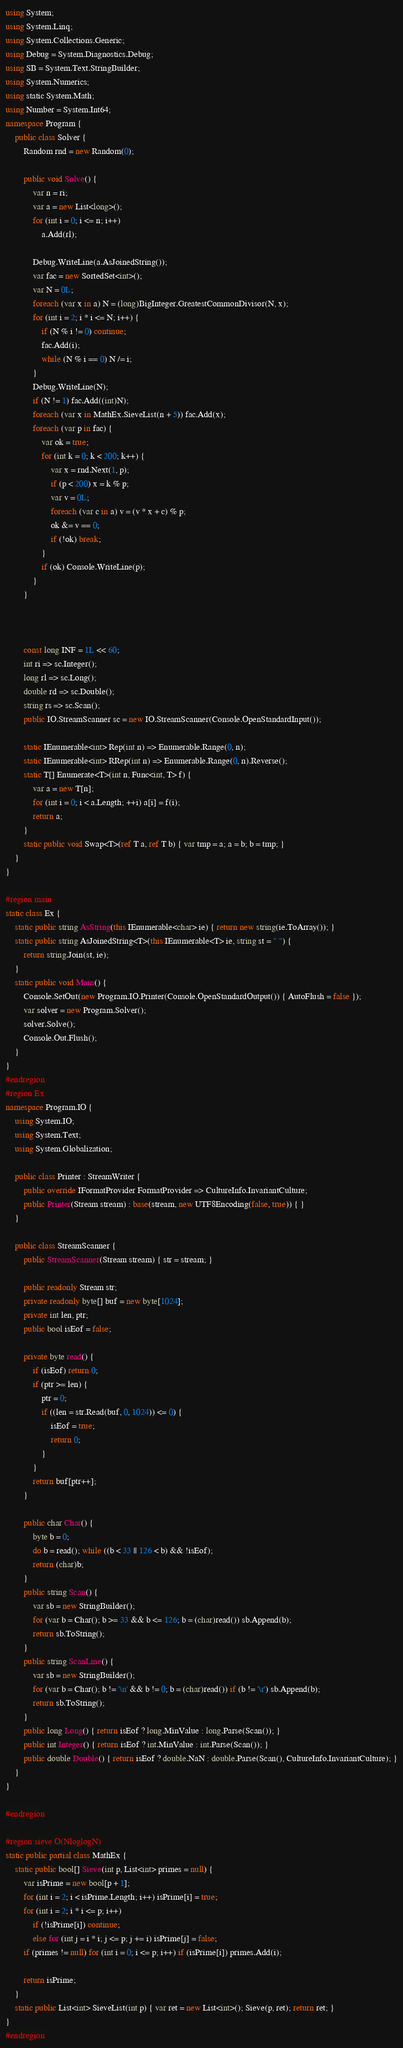Convert code to text. <code><loc_0><loc_0><loc_500><loc_500><_C#_>using System;
using System.Linq;
using System.Collections.Generic;
using Debug = System.Diagnostics.Debug;
using SB = System.Text.StringBuilder;
using System.Numerics;
using static System.Math;
using Number = System.Int64;
namespace Program {
    public class Solver {
        Random rnd = new Random(0);

        public void Solve() {
            var n = ri;
            var a = new List<long>();
            for (int i = 0; i <= n; i++)
                a.Add(rl);

            Debug.WriteLine(a.AsJoinedString());
            var fac = new SortedSet<int>();
            var N = 0L;
            foreach (var x in a) N = (long)BigInteger.GreatestCommonDivisor(N, x);
            for (int i = 2; i * i <= N; i++) {
                if (N % i != 0) continue;
                fac.Add(i);
                while (N % i == 0) N /= i;
            }
            Debug.WriteLine(N);
            if (N != 1) fac.Add((int)N);
            foreach (var x in MathEx.SieveList(n + 5)) fac.Add(x);
            foreach (var p in fac) {
                var ok = true;
                for (int k = 0; k < 200; k++) {
                    var x = rnd.Next(1, p);
                    if (p < 200) x = k % p;
                    var v = 0L;
                    foreach (var c in a) v = (v * x + c) % p;
                    ok &= v == 0;
                    if (!ok) break;
                }
                if (ok) Console.WriteLine(p);
            }
        }



        const long INF = 1L << 60;
        int ri => sc.Integer();
        long rl => sc.Long();
        double rd => sc.Double();
        string rs => sc.Scan();
        public IO.StreamScanner sc = new IO.StreamScanner(Console.OpenStandardInput());

        static IEnumerable<int> Rep(int n) => Enumerable.Range(0, n);
        static IEnumerable<int> RRep(int n) => Enumerable.Range(0, n).Reverse();
        static T[] Enumerate<T>(int n, Func<int, T> f) {
            var a = new T[n];
            for (int i = 0; i < a.Length; ++i) a[i] = f(i);
            return a;
        }
        static public void Swap<T>(ref T a, ref T b) { var tmp = a; a = b; b = tmp; }
    }
}

#region main
static class Ex {
    static public string AsString(this IEnumerable<char> ie) { return new string(ie.ToArray()); }
    static public string AsJoinedString<T>(this IEnumerable<T> ie, string st = " ") {
        return string.Join(st, ie);
    }
    static public void Main() {
        Console.SetOut(new Program.IO.Printer(Console.OpenStandardOutput()) { AutoFlush = false });
        var solver = new Program.Solver();
        solver.Solve();
        Console.Out.Flush();
    }
}
#endregion
#region Ex
namespace Program.IO {
    using System.IO;
    using System.Text;
    using System.Globalization;

    public class Printer : StreamWriter {
        public override IFormatProvider FormatProvider => CultureInfo.InvariantCulture;
        public Printer(Stream stream) : base(stream, new UTF8Encoding(false, true)) { }
    }

    public class StreamScanner {
        public StreamScanner(Stream stream) { str = stream; }

        public readonly Stream str;
        private readonly byte[] buf = new byte[1024];
        private int len, ptr;
        public bool isEof = false;

        private byte read() {
            if (isEof) return 0;
            if (ptr >= len) {
                ptr = 0;
                if ((len = str.Read(buf, 0, 1024)) <= 0) {
                    isEof = true;
                    return 0;
                }
            }
            return buf[ptr++];
        }

        public char Char() {
            byte b = 0;
            do b = read(); while ((b < 33 || 126 < b) && !isEof);
            return (char)b;
        }
        public string Scan() {
            var sb = new StringBuilder();
            for (var b = Char(); b >= 33 && b <= 126; b = (char)read()) sb.Append(b);
            return sb.ToString();
        }
        public string ScanLine() {
            var sb = new StringBuilder();
            for (var b = Char(); b != '\n' && b != 0; b = (char)read()) if (b != '\r') sb.Append(b);
            return sb.ToString();
        }
        public long Long() { return isEof ? long.MinValue : long.Parse(Scan()); }
        public int Integer() { return isEof ? int.MinValue : int.Parse(Scan()); }
        public double Double() { return isEof ? double.NaN : double.Parse(Scan(), CultureInfo.InvariantCulture); }
    }
}

#endregion

#region sieve O(NloglogN)
static public partial class MathEx {
    static public bool[] Sieve(int p, List<int> primes = null) {
        var isPrime = new bool[p + 1];
        for (int i = 2; i < isPrime.Length; i++) isPrime[i] = true;
        for (int i = 2; i * i <= p; i++)
            if (!isPrime[i]) continue;
            else for (int j = i * i; j <= p; j += i) isPrime[j] = false;
        if (primes != null) for (int i = 0; i <= p; i++) if (isPrime[i]) primes.Add(i);

        return isPrime;
    }
    static public List<int> SieveList(int p) { var ret = new List<int>(); Sieve(p, ret); return ret; }
}
#endregion</code> 